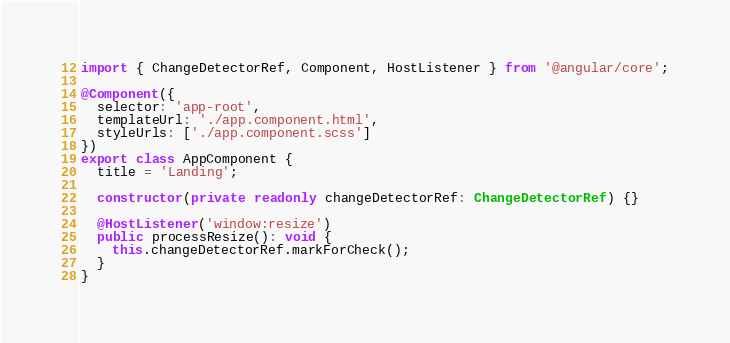Convert code to text. <code><loc_0><loc_0><loc_500><loc_500><_TypeScript_>import { ChangeDetectorRef, Component, HostListener } from '@angular/core';

@Component({
  selector: 'app-root',
  templateUrl: './app.component.html',
  styleUrls: ['./app.component.scss']
})
export class AppComponent {
  title = 'Landing';

  constructor(private readonly changeDetectorRef: ChangeDetectorRef) {}

  @HostListener('window:resize')
  public processResize(): void {
    this.changeDetectorRef.markForCheck();
  }
}
</code> 